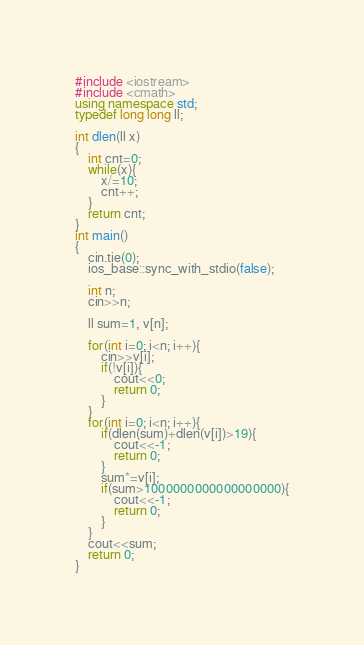<code> <loc_0><loc_0><loc_500><loc_500><_C++_>#include <iostream>
#include <cmath>
using namespace std;
typedef long long ll;

int dlen(ll x)
{
    int cnt=0;
    while(x){
        x/=10;
        cnt++;
    }
    return cnt;
}
int main()
{
    cin.tie(0);
    ios_base::sync_with_stdio(false);

    int n;
    cin>>n;

    ll sum=1, v[n];

    for(int i=0; i<n; i++){
        cin>>v[i];
        if(!v[i]){
            cout<<0;
            return 0;
        }
    }
    for(int i=0; i<n; i++){
        if(dlen(sum)+dlen(v[i])>19){
            cout<<-1;
            return 0;
        }
        sum*=v[i];
        if(sum>1000000000000000000){
            cout<<-1;
            return 0;
        }
    }
    cout<<sum;
    return 0;
}</code> 